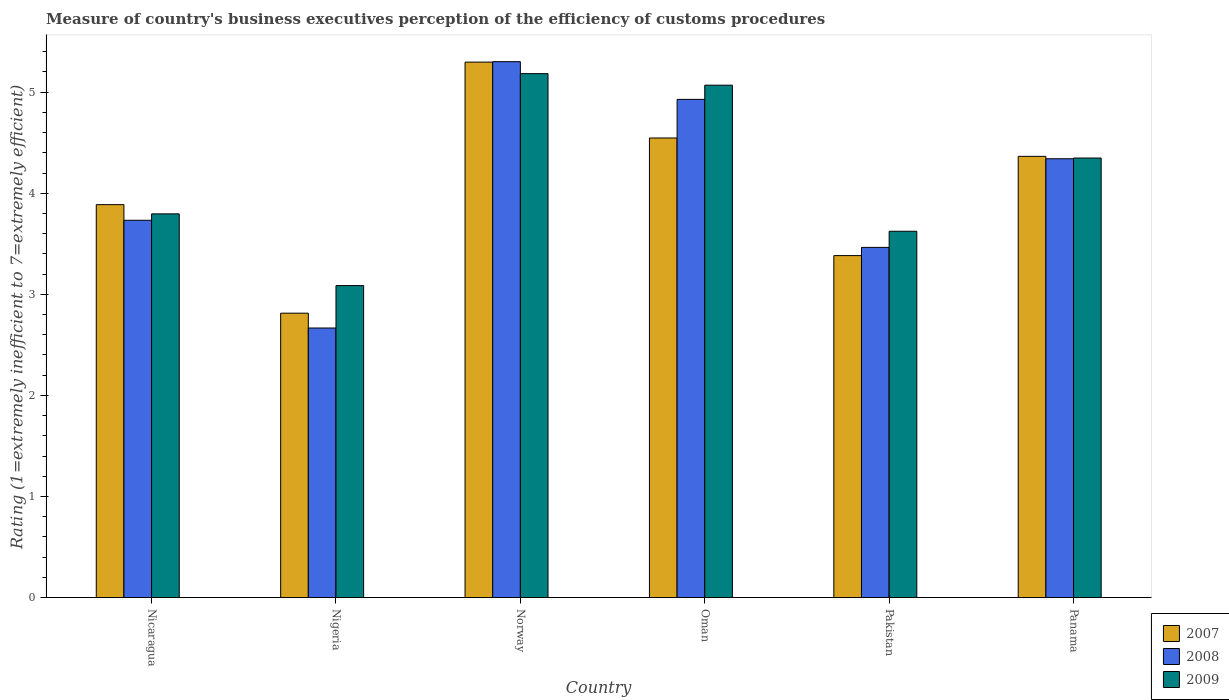Are the number of bars per tick equal to the number of legend labels?
Ensure brevity in your answer.  Yes. Are the number of bars on each tick of the X-axis equal?
Provide a succinct answer. Yes. How many bars are there on the 2nd tick from the right?
Your answer should be compact. 3. What is the label of the 1st group of bars from the left?
Offer a very short reply. Nicaragua. What is the rating of the efficiency of customs procedure in 2008 in Nicaragua?
Make the answer very short. 3.73. Across all countries, what is the maximum rating of the efficiency of customs procedure in 2009?
Offer a very short reply. 5.18. Across all countries, what is the minimum rating of the efficiency of customs procedure in 2008?
Keep it short and to the point. 2.67. In which country was the rating of the efficiency of customs procedure in 2008 minimum?
Your answer should be very brief. Nigeria. What is the total rating of the efficiency of customs procedure in 2008 in the graph?
Offer a very short reply. 24.43. What is the difference between the rating of the efficiency of customs procedure in 2007 in Nicaragua and that in Nigeria?
Your answer should be compact. 1.07. What is the difference between the rating of the efficiency of customs procedure in 2008 in Norway and the rating of the efficiency of customs procedure in 2007 in Oman?
Keep it short and to the point. 0.76. What is the average rating of the efficiency of customs procedure in 2009 per country?
Your answer should be very brief. 4.18. What is the difference between the rating of the efficiency of customs procedure of/in 2007 and rating of the efficiency of customs procedure of/in 2009 in Norway?
Keep it short and to the point. 0.11. What is the ratio of the rating of the efficiency of customs procedure in 2008 in Nigeria to that in Pakistan?
Keep it short and to the point. 0.77. Is the rating of the efficiency of customs procedure in 2007 in Nicaragua less than that in Nigeria?
Your answer should be compact. No. What is the difference between the highest and the second highest rating of the efficiency of customs procedure in 2009?
Your response must be concise. 0.72. What is the difference between the highest and the lowest rating of the efficiency of customs procedure in 2007?
Your answer should be very brief. 2.48. Is it the case that in every country, the sum of the rating of the efficiency of customs procedure in 2007 and rating of the efficiency of customs procedure in 2008 is greater than the rating of the efficiency of customs procedure in 2009?
Your response must be concise. Yes. How many bars are there?
Your response must be concise. 18. What is the difference between two consecutive major ticks on the Y-axis?
Offer a terse response. 1. Are the values on the major ticks of Y-axis written in scientific E-notation?
Your answer should be very brief. No. Does the graph contain grids?
Ensure brevity in your answer.  No. Where does the legend appear in the graph?
Give a very brief answer. Bottom right. How many legend labels are there?
Your response must be concise. 3. How are the legend labels stacked?
Ensure brevity in your answer.  Vertical. What is the title of the graph?
Ensure brevity in your answer.  Measure of country's business executives perception of the efficiency of customs procedures. What is the label or title of the X-axis?
Your response must be concise. Country. What is the label or title of the Y-axis?
Your answer should be very brief. Rating (1=extremely inefficient to 7=extremely efficient). What is the Rating (1=extremely inefficient to 7=extremely efficient) of 2007 in Nicaragua?
Offer a terse response. 3.89. What is the Rating (1=extremely inefficient to 7=extremely efficient) in 2008 in Nicaragua?
Your answer should be compact. 3.73. What is the Rating (1=extremely inefficient to 7=extremely efficient) in 2009 in Nicaragua?
Provide a short and direct response. 3.8. What is the Rating (1=extremely inefficient to 7=extremely efficient) in 2007 in Nigeria?
Keep it short and to the point. 2.81. What is the Rating (1=extremely inefficient to 7=extremely efficient) in 2008 in Nigeria?
Your answer should be compact. 2.67. What is the Rating (1=extremely inefficient to 7=extremely efficient) in 2009 in Nigeria?
Your answer should be compact. 3.09. What is the Rating (1=extremely inefficient to 7=extremely efficient) of 2007 in Norway?
Provide a succinct answer. 5.3. What is the Rating (1=extremely inefficient to 7=extremely efficient) in 2008 in Norway?
Offer a very short reply. 5.3. What is the Rating (1=extremely inefficient to 7=extremely efficient) of 2009 in Norway?
Your answer should be very brief. 5.18. What is the Rating (1=extremely inefficient to 7=extremely efficient) in 2007 in Oman?
Keep it short and to the point. 4.55. What is the Rating (1=extremely inefficient to 7=extremely efficient) of 2008 in Oman?
Offer a terse response. 4.93. What is the Rating (1=extremely inefficient to 7=extremely efficient) in 2009 in Oman?
Your answer should be very brief. 5.07. What is the Rating (1=extremely inefficient to 7=extremely efficient) in 2007 in Pakistan?
Give a very brief answer. 3.38. What is the Rating (1=extremely inefficient to 7=extremely efficient) of 2008 in Pakistan?
Offer a very short reply. 3.46. What is the Rating (1=extremely inefficient to 7=extremely efficient) of 2009 in Pakistan?
Ensure brevity in your answer.  3.62. What is the Rating (1=extremely inefficient to 7=extremely efficient) of 2007 in Panama?
Make the answer very short. 4.36. What is the Rating (1=extremely inefficient to 7=extremely efficient) in 2008 in Panama?
Make the answer very short. 4.34. What is the Rating (1=extremely inefficient to 7=extremely efficient) in 2009 in Panama?
Keep it short and to the point. 4.35. Across all countries, what is the maximum Rating (1=extremely inefficient to 7=extremely efficient) of 2007?
Offer a very short reply. 5.3. Across all countries, what is the maximum Rating (1=extremely inefficient to 7=extremely efficient) of 2008?
Provide a short and direct response. 5.3. Across all countries, what is the maximum Rating (1=extremely inefficient to 7=extremely efficient) of 2009?
Your response must be concise. 5.18. Across all countries, what is the minimum Rating (1=extremely inefficient to 7=extremely efficient) in 2007?
Offer a very short reply. 2.81. Across all countries, what is the minimum Rating (1=extremely inefficient to 7=extremely efficient) of 2008?
Your answer should be very brief. 2.67. Across all countries, what is the minimum Rating (1=extremely inefficient to 7=extremely efficient) of 2009?
Offer a terse response. 3.09. What is the total Rating (1=extremely inefficient to 7=extremely efficient) in 2007 in the graph?
Your answer should be very brief. 24.29. What is the total Rating (1=extremely inefficient to 7=extremely efficient) of 2008 in the graph?
Your response must be concise. 24.43. What is the total Rating (1=extremely inefficient to 7=extremely efficient) in 2009 in the graph?
Give a very brief answer. 25.11. What is the difference between the Rating (1=extremely inefficient to 7=extremely efficient) in 2007 in Nicaragua and that in Nigeria?
Provide a succinct answer. 1.07. What is the difference between the Rating (1=extremely inefficient to 7=extremely efficient) of 2008 in Nicaragua and that in Nigeria?
Provide a succinct answer. 1.07. What is the difference between the Rating (1=extremely inefficient to 7=extremely efficient) in 2009 in Nicaragua and that in Nigeria?
Give a very brief answer. 0.71. What is the difference between the Rating (1=extremely inefficient to 7=extremely efficient) of 2007 in Nicaragua and that in Norway?
Make the answer very short. -1.41. What is the difference between the Rating (1=extremely inefficient to 7=extremely efficient) of 2008 in Nicaragua and that in Norway?
Provide a succinct answer. -1.57. What is the difference between the Rating (1=extremely inefficient to 7=extremely efficient) in 2009 in Nicaragua and that in Norway?
Your answer should be very brief. -1.39. What is the difference between the Rating (1=extremely inefficient to 7=extremely efficient) in 2007 in Nicaragua and that in Oman?
Offer a terse response. -0.66. What is the difference between the Rating (1=extremely inefficient to 7=extremely efficient) of 2008 in Nicaragua and that in Oman?
Make the answer very short. -1.2. What is the difference between the Rating (1=extremely inefficient to 7=extremely efficient) of 2009 in Nicaragua and that in Oman?
Keep it short and to the point. -1.27. What is the difference between the Rating (1=extremely inefficient to 7=extremely efficient) in 2007 in Nicaragua and that in Pakistan?
Make the answer very short. 0.5. What is the difference between the Rating (1=extremely inefficient to 7=extremely efficient) of 2008 in Nicaragua and that in Pakistan?
Keep it short and to the point. 0.27. What is the difference between the Rating (1=extremely inefficient to 7=extremely efficient) in 2009 in Nicaragua and that in Pakistan?
Give a very brief answer. 0.17. What is the difference between the Rating (1=extremely inefficient to 7=extremely efficient) of 2007 in Nicaragua and that in Panama?
Ensure brevity in your answer.  -0.48. What is the difference between the Rating (1=extremely inefficient to 7=extremely efficient) in 2008 in Nicaragua and that in Panama?
Keep it short and to the point. -0.61. What is the difference between the Rating (1=extremely inefficient to 7=extremely efficient) of 2009 in Nicaragua and that in Panama?
Offer a terse response. -0.55. What is the difference between the Rating (1=extremely inefficient to 7=extremely efficient) in 2007 in Nigeria and that in Norway?
Offer a very short reply. -2.48. What is the difference between the Rating (1=extremely inefficient to 7=extremely efficient) in 2008 in Nigeria and that in Norway?
Provide a short and direct response. -2.64. What is the difference between the Rating (1=extremely inefficient to 7=extremely efficient) in 2009 in Nigeria and that in Norway?
Give a very brief answer. -2.1. What is the difference between the Rating (1=extremely inefficient to 7=extremely efficient) of 2007 in Nigeria and that in Oman?
Ensure brevity in your answer.  -1.73. What is the difference between the Rating (1=extremely inefficient to 7=extremely efficient) of 2008 in Nigeria and that in Oman?
Offer a very short reply. -2.26. What is the difference between the Rating (1=extremely inefficient to 7=extremely efficient) in 2009 in Nigeria and that in Oman?
Provide a short and direct response. -1.98. What is the difference between the Rating (1=extremely inefficient to 7=extremely efficient) in 2007 in Nigeria and that in Pakistan?
Keep it short and to the point. -0.57. What is the difference between the Rating (1=extremely inefficient to 7=extremely efficient) of 2008 in Nigeria and that in Pakistan?
Provide a succinct answer. -0.8. What is the difference between the Rating (1=extremely inefficient to 7=extremely efficient) of 2009 in Nigeria and that in Pakistan?
Make the answer very short. -0.54. What is the difference between the Rating (1=extremely inefficient to 7=extremely efficient) of 2007 in Nigeria and that in Panama?
Your answer should be very brief. -1.55. What is the difference between the Rating (1=extremely inefficient to 7=extremely efficient) of 2008 in Nigeria and that in Panama?
Your answer should be compact. -1.67. What is the difference between the Rating (1=extremely inefficient to 7=extremely efficient) in 2009 in Nigeria and that in Panama?
Keep it short and to the point. -1.26. What is the difference between the Rating (1=extremely inefficient to 7=extremely efficient) of 2007 in Norway and that in Oman?
Provide a short and direct response. 0.75. What is the difference between the Rating (1=extremely inefficient to 7=extremely efficient) of 2008 in Norway and that in Oman?
Offer a very short reply. 0.37. What is the difference between the Rating (1=extremely inefficient to 7=extremely efficient) in 2009 in Norway and that in Oman?
Provide a succinct answer. 0.11. What is the difference between the Rating (1=extremely inefficient to 7=extremely efficient) of 2007 in Norway and that in Pakistan?
Offer a terse response. 1.91. What is the difference between the Rating (1=extremely inefficient to 7=extremely efficient) in 2008 in Norway and that in Pakistan?
Your answer should be very brief. 1.84. What is the difference between the Rating (1=extremely inefficient to 7=extremely efficient) of 2009 in Norway and that in Pakistan?
Keep it short and to the point. 1.56. What is the difference between the Rating (1=extremely inefficient to 7=extremely efficient) of 2007 in Norway and that in Panama?
Your answer should be compact. 0.93. What is the difference between the Rating (1=extremely inefficient to 7=extremely efficient) of 2008 in Norway and that in Panama?
Your answer should be compact. 0.96. What is the difference between the Rating (1=extremely inefficient to 7=extremely efficient) in 2009 in Norway and that in Panama?
Offer a terse response. 0.83. What is the difference between the Rating (1=extremely inefficient to 7=extremely efficient) in 2007 in Oman and that in Pakistan?
Your answer should be compact. 1.16. What is the difference between the Rating (1=extremely inefficient to 7=extremely efficient) of 2008 in Oman and that in Pakistan?
Keep it short and to the point. 1.46. What is the difference between the Rating (1=extremely inefficient to 7=extremely efficient) in 2009 in Oman and that in Pakistan?
Keep it short and to the point. 1.45. What is the difference between the Rating (1=extremely inefficient to 7=extremely efficient) in 2007 in Oman and that in Panama?
Your answer should be very brief. 0.18. What is the difference between the Rating (1=extremely inefficient to 7=extremely efficient) in 2008 in Oman and that in Panama?
Keep it short and to the point. 0.59. What is the difference between the Rating (1=extremely inefficient to 7=extremely efficient) of 2009 in Oman and that in Panama?
Provide a short and direct response. 0.72. What is the difference between the Rating (1=extremely inefficient to 7=extremely efficient) of 2007 in Pakistan and that in Panama?
Ensure brevity in your answer.  -0.98. What is the difference between the Rating (1=extremely inefficient to 7=extremely efficient) of 2008 in Pakistan and that in Panama?
Ensure brevity in your answer.  -0.88. What is the difference between the Rating (1=extremely inefficient to 7=extremely efficient) of 2009 in Pakistan and that in Panama?
Provide a short and direct response. -0.72. What is the difference between the Rating (1=extremely inefficient to 7=extremely efficient) in 2007 in Nicaragua and the Rating (1=extremely inefficient to 7=extremely efficient) in 2008 in Nigeria?
Give a very brief answer. 1.22. What is the difference between the Rating (1=extremely inefficient to 7=extremely efficient) of 2007 in Nicaragua and the Rating (1=extremely inefficient to 7=extremely efficient) of 2009 in Nigeria?
Provide a short and direct response. 0.8. What is the difference between the Rating (1=extremely inefficient to 7=extremely efficient) in 2008 in Nicaragua and the Rating (1=extremely inefficient to 7=extremely efficient) in 2009 in Nigeria?
Ensure brevity in your answer.  0.65. What is the difference between the Rating (1=extremely inefficient to 7=extremely efficient) of 2007 in Nicaragua and the Rating (1=extremely inefficient to 7=extremely efficient) of 2008 in Norway?
Provide a short and direct response. -1.41. What is the difference between the Rating (1=extremely inefficient to 7=extremely efficient) of 2007 in Nicaragua and the Rating (1=extremely inefficient to 7=extremely efficient) of 2009 in Norway?
Keep it short and to the point. -1.3. What is the difference between the Rating (1=extremely inefficient to 7=extremely efficient) in 2008 in Nicaragua and the Rating (1=extremely inefficient to 7=extremely efficient) in 2009 in Norway?
Provide a succinct answer. -1.45. What is the difference between the Rating (1=extremely inefficient to 7=extremely efficient) of 2007 in Nicaragua and the Rating (1=extremely inefficient to 7=extremely efficient) of 2008 in Oman?
Offer a terse response. -1.04. What is the difference between the Rating (1=extremely inefficient to 7=extremely efficient) of 2007 in Nicaragua and the Rating (1=extremely inefficient to 7=extremely efficient) of 2009 in Oman?
Make the answer very short. -1.18. What is the difference between the Rating (1=extremely inefficient to 7=extremely efficient) of 2008 in Nicaragua and the Rating (1=extremely inefficient to 7=extremely efficient) of 2009 in Oman?
Offer a very short reply. -1.34. What is the difference between the Rating (1=extremely inefficient to 7=extremely efficient) in 2007 in Nicaragua and the Rating (1=extremely inefficient to 7=extremely efficient) in 2008 in Pakistan?
Offer a terse response. 0.42. What is the difference between the Rating (1=extremely inefficient to 7=extremely efficient) of 2007 in Nicaragua and the Rating (1=extremely inefficient to 7=extremely efficient) of 2009 in Pakistan?
Keep it short and to the point. 0.26. What is the difference between the Rating (1=extremely inefficient to 7=extremely efficient) in 2008 in Nicaragua and the Rating (1=extremely inefficient to 7=extremely efficient) in 2009 in Pakistan?
Provide a succinct answer. 0.11. What is the difference between the Rating (1=extremely inefficient to 7=extremely efficient) of 2007 in Nicaragua and the Rating (1=extremely inefficient to 7=extremely efficient) of 2008 in Panama?
Provide a succinct answer. -0.45. What is the difference between the Rating (1=extremely inefficient to 7=extremely efficient) in 2007 in Nicaragua and the Rating (1=extremely inefficient to 7=extremely efficient) in 2009 in Panama?
Provide a short and direct response. -0.46. What is the difference between the Rating (1=extremely inefficient to 7=extremely efficient) of 2008 in Nicaragua and the Rating (1=extremely inefficient to 7=extremely efficient) of 2009 in Panama?
Give a very brief answer. -0.62. What is the difference between the Rating (1=extremely inefficient to 7=extremely efficient) in 2007 in Nigeria and the Rating (1=extremely inefficient to 7=extremely efficient) in 2008 in Norway?
Ensure brevity in your answer.  -2.49. What is the difference between the Rating (1=extremely inefficient to 7=extremely efficient) of 2007 in Nigeria and the Rating (1=extremely inefficient to 7=extremely efficient) of 2009 in Norway?
Your answer should be compact. -2.37. What is the difference between the Rating (1=extremely inefficient to 7=extremely efficient) in 2008 in Nigeria and the Rating (1=extremely inefficient to 7=extremely efficient) in 2009 in Norway?
Offer a terse response. -2.52. What is the difference between the Rating (1=extremely inefficient to 7=extremely efficient) in 2007 in Nigeria and the Rating (1=extremely inefficient to 7=extremely efficient) in 2008 in Oman?
Offer a very short reply. -2.12. What is the difference between the Rating (1=extremely inefficient to 7=extremely efficient) of 2007 in Nigeria and the Rating (1=extremely inefficient to 7=extremely efficient) of 2009 in Oman?
Your response must be concise. -2.26. What is the difference between the Rating (1=extremely inefficient to 7=extremely efficient) of 2008 in Nigeria and the Rating (1=extremely inefficient to 7=extremely efficient) of 2009 in Oman?
Make the answer very short. -2.4. What is the difference between the Rating (1=extremely inefficient to 7=extremely efficient) of 2007 in Nigeria and the Rating (1=extremely inefficient to 7=extremely efficient) of 2008 in Pakistan?
Keep it short and to the point. -0.65. What is the difference between the Rating (1=extremely inefficient to 7=extremely efficient) in 2007 in Nigeria and the Rating (1=extremely inefficient to 7=extremely efficient) in 2009 in Pakistan?
Provide a short and direct response. -0.81. What is the difference between the Rating (1=extremely inefficient to 7=extremely efficient) of 2008 in Nigeria and the Rating (1=extremely inefficient to 7=extremely efficient) of 2009 in Pakistan?
Provide a short and direct response. -0.96. What is the difference between the Rating (1=extremely inefficient to 7=extremely efficient) in 2007 in Nigeria and the Rating (1=extremely inefficient to 7=extremely efficient) in 2008 in Panama?
Offer a very short reply. -1.53. What is the difference between the Rating (1=extremely inefficient to 7=extremely efficient) of 2007 in Nigeria and the Rating (1=extremely inefficient to 7=extremely efficient) of 2009 in Panama?
Give a very brief answer. -1.53. What is the difference between the Rating (1=extremely inefficient to 7=extremely efficient) of 2008 in Nigeria and the Rating (1=extremely inefficient to 7=extremely efficient) of 2009 in Panama?
Your answer should be very brief. -1.68. What is the difference between the Rating (1=extremely inefficient to 7=extremely efficient) in 2007 in Norway and the Rating (1=extremely inefficient to 7=extremely efficient) in 2008 in Oman?
Provide a succinct answer. 0.37. What is the difference between the Rating (1=extremely inefficient to 7=extremely efficient) of 2007 in Norway and the Rating (1=extremely inefficient to 7=extremely efficient) of 2009 in Oman?
Provide a short and direct response. 0.23. What is the difference between the Rating (1=extremely inefficient to 7=extremely efficient) of 2008 in Norway and the Rating (1=extremely inefficient to 7=extremely efficient) of 2009 in Oman?
Keep it short and to the point. 0.23. What is the difference between the Rating (1=extremely inefficient to 7=extremely efficient) of 2007 in Norway and the Rating (1=extremely inefficient to 7=extremely efficient) of 2008 in Pakistan?
Ensure brevity in your answer.  1.83. What is the difference between the Rating (1=extremely inefficient to 7=extremely efficient) of 2007 in Norway and the Rating (1=extremely inefficient to 7=extremely efficient) of 2009 in Pakistan?
Your answer should be very brief. 1.67. What is the difference between the Rating (1=extremely inefficient to 7=extremely efficient) in 2008 in Norway and the Rating (1=extremely inefficient to 7=extremely efficient) in 2009 in Pakistan?
Give a very brief answer. 1.68. What is the difference between the Rating (1=extremely inefficient to 7=extremely efficient) of 2007 in Norway and the Rating (1=extremely inefficient to 7=extremely efficient) of 2008 in Panama?
Provide a succinct answer. 0.96. What is the difference between the Rating (1=extremely inefficient to 7=extremely efficient) of 2007 in Norway and the Rating (1=extremely inefficient to 7=extremely efficient) of 2009 in Panama?
Offer a terse response. 0.95. What is the difference between the Rating (1=extremely inefficient to 7=extremely efficient) of 2008 in Norway and the Rating (1=extremely inefficient to 7=extremely efficient) of 2009 in Panama?
Your response must be concise. 0.95. What is the difference between the Rating (1=extremely inefficient to 7=extremely efficient) in 2007 in Oman and the Rating (1=extremely inefficient to 7=extremely efficient) in 2008 in Pakistan?
Your response must be concise. 1.08. What is the difference between the Rating (1=extremely inefficient to 7=extremely efficient) in 2007 in Oman and the Rating (1=extremely inefficient to 7=extremely efficient) in 2009 in Pakistan?
Provide a succinct answer. 0.92. What is the difference between the Rating (1=extremely inefficient to 7=extremely efficient) in 2008 in Oman and the Rating (1=extremely inefficient to 7=extremely efficient) in 2009 in Pakistan?
Offer a terse response. 1.3. What is the difference between the Rating (1=extremely inefficient to 7=extremely efficient) of 2007 in Oman and the Rating (1=extremely inefficient to 7=extremely efficient) of 2008 in Panama?
Make the answer very short. 0.21. What is the difference between the Rating (1=extremely inefficient to 7=extremely efficient) of 2007 in Oman and the Rating (1=extremely inefficient to 7=extremely efficient) of 2009 in Panama?
Your response must be concise. 0.2. What is the difference between the Rating (1=extremely inefficient to 7=extremely efficient) of 2008 in Oman and the Rating (1=extremely inefficient to 7=extremely efficient) of 2009 in Panama?
Provide a succinct answer. 0.58. What is the difference between the Rating (1=extremely inefficient to 7=extremely efficient) of 2007 in Pakistan and the Rating (1=extremely inefficient to 7=extremely efficient) of 2008 in Panama?
Provide a succinct answer. -0.96. What is the difference between the Rating (1=extremely inefficient to 7=extremely efficient) in 2007 in Pakistan and the Rating (1=extremely inefficient to 7=extremely efficient) in 2009 in Panama?
Provide a short and direct response. -0.97. What is the difference between the Rating (1=extremely inefficient to 7=extremely efficient) of 2008 in Pakistan and the Rating (1=extremely inefficient to 7=extremely efficient) of 2009 in Panama?
Keep it short and to the point. -0.88. What is the average Rating (1=extremely inefficient to 7=extremely efficient) in 2007 per country?
Offer a terse response. 4.05. What is the average Rating (1=extremely inefficient to 7=extremely efficient) in 2008 per country?
Your response must be concise. 4.07. What is the average Rating (1=extremely inefficient to 7=extremely efficient) in 2009 per country?
Your answer should be very brief. 4.18. What is the difference between the Rating (1=extremely inefficient to 7=extremely efficient) of 2007 and Rating (1=extremely inefficient to 7=extremely efficient) of 2008 in Nicaragua?
Provide a short and direct response. 0.15. What is the difference between the Rating (1=extremely inefficient to 7=extremely efficient) in 2007 and Rating (1=extremely inefficient to 7=extremely efficient) in 2009 in Nicaragua?
Give a very brief answer. 0.09. What is the difference between the Rating (1=extremely inefficient to 7=extremely efficient) in 2008 and Rating (1=extremely inefficient to 7=extremely efficient) in 2009 in Nicaragua?
Give a very brief answer. -0.06. What is the difference between the Rating (1=extremely inefficient to 7=extremely efficient) in 2007 and Rating (1=extremely inefficient to 7=extremely efficient) in 2008 in Nigeria?
Offer a very short reply. 0.15. What is the difference between the Rating (1=extremely inefficient to 7=extremely efficient) of 2007 and Rating (1=extremely inefficient to 7=extremely efficient) of 2009 in Nigeria?
Your answer should be compact. -0.27. What is the difference between the Rating (1=extremely inefficient to 7=extremely efficient) in 2008 and Rating (1=extremely inefficient to 7=extremely efficient) in 2009 in Nigeria?
Make the answer very short. -0.42. What is the difference between the Rating (1=extremely inefficient to 7=extremely efficient) in 2007 and Rating (1=extremely inefficient to 7=extremely efficient) in 2008 in Norway?
Provide a short and direct response. -0. What is the difference between the Rating (1=extremely inefficient to 7=extremely efficient) in 2007 and Rating (1=extremely inefficient to 7=extremely efficient) in 2009 in Norway?
Your answer should be very brief. 0.11. What is the difference between the Rating (1=extremely inefficient to 7=extremely efficient) of 2008 and Rating (1=extremely inefficient to 7=extremely efficient) of 2009 in Norway?
Your response must be concise. 0.12. What is the difference between the Rating (1=extremely inefficient to 7=extremely efficient) in 2007 and Rating (1=extremely inefficient to 7=extremely efficient) in 2008 in Oman?
Provide a succinct answer. -0.38. What is the difference between the Rating (1=extremely inefficient to 7=extremely efficient) in 2007 and Rating (1=extremely inefficient to 7=extremely efficient) in 2009 in Oman?
Make the answer very short. -0.52. What is the difference between the Rating (1=extremely inefficient to 7=extremely efficient) of 2008 and Rating (1=extremely inefficient to 7=extremely efficient) of 2009 in Oman?
Your answer should be very brief. -0.14. What is the difference between the Rating (1=extremely inefficient to 7=extremely efficient) in 2007 and Rating (1=extremely inefficient to 7=extremely efficient) in 2008 in Pakistan?
Provide a succinct answer. -0.08. What is the difference between the Rating (1=extremely inefficient to 7=extremely efficient) in 2007 and Rating (1=extremely inefficient to 7=extremely efficient) in 2009 in Pakistan?
Your response must be concise. -0.24. What is the difference between the Rating (1=extremely inefficient to 7=extremely efficient) of 2008 and Rating (1=extremely inefficient to 7=extremely efficient) of 2009 in Pakistan?
Offer a terse response. -0.16. What is the difference between the Rating (1=extremely inefficient to 7=extremely efficient) in 2007 and Rating (1=extremely inefficient to 7=extremely efficient) in 2008 in Panama?
Provide a succinct answer. 0.02. What is the difference between the Rating (1=extremely inefficient to 7=extremely efficient) of 2007 and Rating (1=extremely inefficient to 7=extremely efficient) of 2009 in Panama?
Keep it short and to the point. 0.02. What is the difference between the Rating (1=extremely inefficient to 7=extremely efficient) of 2008 and Rating (1=extremely inefficient to 7=extremely efficient) of 2009 in Panama?
Provide a succinct answer. -0.01. What is the ratio of the Rating (1=extremely inefficient to 7=extremely efficient) of 2007 in Nicaragua to that in Nigeria?
Your answer should be very brief. 1.38. What is the ratio of the Rating (1=extremely inefficient to 7=extremely efficient) in 2008 in Nicaragua to that in Nigeria?
Make the answer very short. 1.4. What is the ratio of the Rating (1=extremely inefficient to 7=extremely efficient) in 2009 in Nicaragua to that in Nigeria?
Offer a terse response. 1.23. What is the ratio of the Rating (1=extremely inefficient to 7=extremely efficient) of 2007 in Nicaragua to that in Norway?
Your answer should be very brief. 0.73. What is the ratio of the Rating (1=extremely inefficient to 7=extremely efficient) of 2008 in Nicaragua to that in Norway?
Your answer should be very brief. 0.7. What is the ratio of the Rating (1=extremely inefficient to 7=extremely efficient) in 2009 in Nicaragua to that in Norway?
Your response must be concise. 0.73. What is the ratio of the Rating (1=extremely inefficient to 7=extremely efficient) of 2007 in Nicaragua to that in Oman?
Your answer should be very brief. 0.85. What is the ratio of the Rating (1=extremely inefficient to 7=extremely efficient) in 2008 in Nicaragua to that in Oman?
Keep it short and to the point. 0.76. What is the ratio of the Rating (1=extremely inefficient to 7=extremely efficient) in 2009 in Nicaragua to that in Oman?
Provide a short and direct response. 0.75. What is the ratio of the Rating (1=extremely inefficient to 7=extremely efficient) in 2007 in Nicaragua to that in Pakistan?
Offer a very short reply. 1.15. What is the ratio of the Rating (1=extremely inefficient to 7=extremely efficient) in 2008 in Nicaragua to that in Pakistan?
Ensure brevity in your answer.  1.08. What is the ratio of the Rating (1=extremely inefficient to 7=extremely efficient) in 2009 in Nicaragua to that in Pakistan?
Keep it short and to the point. 1.05. What is the ratio of the Rating (1=extremely inefficient to 7=extremely efficient) of 2007 in Nicaragua to that in Panama?
Offer a very short reply. 0.89. What is the ratio of the Rating (1=extremely inefficient to 7=extremely efficient) of 2008 in Nicaragua to that in Panama?
Provide a short and direct response. 0.86. What is the ratio of the Rating (1=extremely inefficient to 7=extremely efficient) of 2009 in Nicaragua to that in Panama?
Your answer should be compact. 0.87. What is the ratio of the Rating (1=extremely inefficient to 7=extremely efficient) in 2007 in Nigeria to that in Norway?
Provide a succinct answer. 0.53. What is the ratio of the Rating (1=extremely inefficient to 7=extremely efficient) in 2008 in Nigeria to that in Norway?
Provide a short and direct response. 0.5. What is the ratio of the Rating (1=extremely inefficient to 7=extremely efficient) in 2009 in Nigeria to that in Norway?
Offer a very short reply. 0.6. What is the ratio of the Rating (1=extremely inefficient to 7=extremely efficient) in 2007 in Nigeria to that in Oman?
Make the answer very short. 0.62. What is the ratio of the Rating (1=extremely inefficient to 7=extremely efficient) of 2008 in Nigeria to that in Oman?
Offer a terse response. 0.54. What is the ratio of the Rating (1=extremely inefficient to 7=extremely efficient) of 2009 in Nigeria to that in Oman?
Provide a short and direct response. 0.61. What is the ratio of the Rating (1=extremely inefficient to 7=extremely efficient) of 2007 in Nigeria to that in Pakistan?
Your response must be concise. 0.83. What is the ratio of the Rating (1=extremely inefficient to 7=extremely efficient) of 2008 in Nigeria to that in Pakistan?
Your answer should be very brief. 0.77. What is the ratio of the Rating (1=extremely inefficient to 7=extremely efficient) of 2009 in Nigeria to that in Pakistan?
Make the answer very short. 0.85. What is the ratio of the Rating (1=extremely inefficient to 7=extremely efficient) in 2007 in Nigeria to that in Panama?
Ensure brevity in your answer.  0.64. What is the ratio of the Rating (1=extremely inefficient to 7=extremely efficient) in 2008 in Nigeria to that in Panama?
Provide a short and direct response. 0.61. What is the ratio of the Rating (1=extremely inefficient to 7=extremely efficient) of 2009 in Nigeria to that in Panama?
Your response must be concise. 0.71. What is the ratio of the Rating (1=extremely inefficient to 7=extremely efficient) of 2007 in Norway to that in Oman?
Offer a very short reply. 1.17. What is the ratio of the Rating (1=extremely inefficient to 7=extremely efficient) of 2008 in Norway to that in Oman?
Offer a terse response. 1.08. What is the ratio of the Rating (1=extremely inefficient to 7=extremely efficient) in 2009 in Norway to that in Oman?
Provide a short and direct response. 1.02. What is the ratio of the Rating (1=extremely inefficient to 7=extremely efficient) in 2007 in Norway to that in Pakistan?
Provide a succinct answer. 1.57. What is the ratio of the Rating (1=extremely inefficient to 7=extremely efficient) of 2008 in Norway to that in Pakistan?
Offer a very short reply. 1.53. What is the ratio of the Rating (1=extremely inefficient to 7=extremely efficient) in 2009 in Norway to that in Pakistan?
Ensure brevity in your answer.  1.43. What is the ratio of the Rating (1=extremely inefficient to 7=extremely efficient) in 2007 in Norway to that in Panama?
Keep it short and to the point. 1.21. What is the ratio of the Rating (1=extremely inefficient to 7=extremely efficient) of 2008 in Norway to that in Panama?
Give a very brief answer. 1.22. What is the ratio of the Rating (1=extremely inefficient to 7=extremely efficient) of 2009 in Norway to that in Panama?
Your answer should be compact. 1.19. What is the ratio of the Rating (1=extremely inefficient to 7=extremely efficient) of 2007 in Oman to that in Pakistan?
Provide a short and direct response. 1.34. What is the ratio of the Rating (1=extremely inefficient to 7=extremely efficient) in 2008 in Oman to that in Pakistan?
Make the answer very short. 1.42. What is the ratio of the Rating (1=extremely inefficient to 7=extremely efficient) of 2009 in Oman to that in Pakistan?
Make the answer very short. 1.4. What is the ratio of the Rating (1=extremely inefficient to 7=extremely efficient) in 2007 in Oman to that in Panama?
Provide a short and direct response. 1.04. What is the ratio of the Rating (1=extremely inefficient to 7=extremely efficient) in 2008 in Oman to that in Panama?
Make the answer very short. 1.14. What is the ratio of the Rating (1=extremely inefficient to 7=extremely efficient) in 2009 in Oman to that in Panama?
Your answer should be very brief. 1.17. What is the ratio of the Rating (1=extremely inefficient to 7=extremely efficient) of 2007 in Pakistan to that in Panama?
Provide a short and direct response. 0.78. What is the ratio of the Rating (1=extremely inefficient to 7=extremely efficient) of 2008 in Pakistan to that in Panama?
Your answer should be compact. 0.8. What is the ratio of the Rating (1=extremely inefficient to 7=extremely efficient) in 2009 in Pakistan to that in Panama?
Make the answer very short. 0.83. What is the difference between the highest and the second highest Rating (1=extremely inefficient to 7=extremely efficient) in 2007?
Your answer should be compact. 0.75. What is the difference between the highest and the second highest Rating (1=extremely inefficient to 7=extremely efficient) of 2008?
Ensure brevity in your answer.  0.37. What is the difference between the highest and the second highest Rating (1=extremely inefficient to 7=extremely efficient) of 2009?
Provide a short and direct response. 0.11. What is the difference between the highest and the lowest Rating (1=extremely inefficient to 7=extremely efficient) in 2007?
Your answer should be compact. 2.48. What is the difference between the highest and the lowest Rating (1=extremely inefficient to 7=extremely efficient) in 2008?
Offer a very short reply. 2.64. What is the difference between the highest and the lowest Rating (1=extremely inefficient to 7=extremely efficient) in 2009?
Provide a succinct answer. 2.1. 